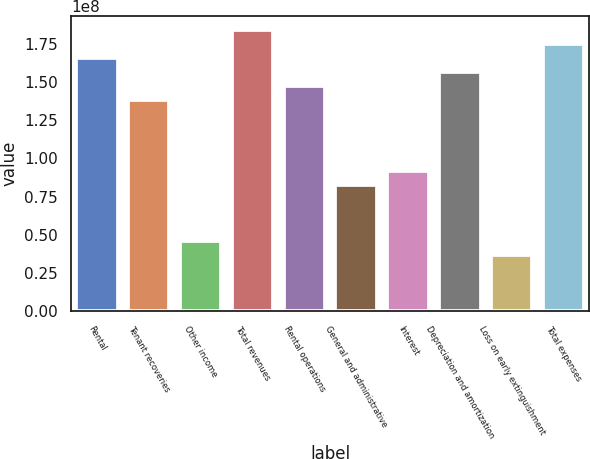Convert chart to OTSL. <chart><loc_0><loc_0><loc_500><loc_500><bar_chart><fcel>Rental<fcel>Tenant recoveries<fcel>Other income<fcel>Total revenues<fcel>Rental operations<fcel>General and administrative<fcel>Interest<fcel>Depreciation and amortization<fcel>Loss on early extinguishment<fcel>Total expenses<nl><fcel>1.65714e+08<fcel>1.38095e+08<fcel>4.60316e+07<fcel>1.84127e+08<fcel>1.47301e+08<fcel>8.28569e+07<fcel>9.20633e+07<fcel>1.56508e+08<fcel>3.68253e+07<fcel>1.7492e+08<nl></chart> 